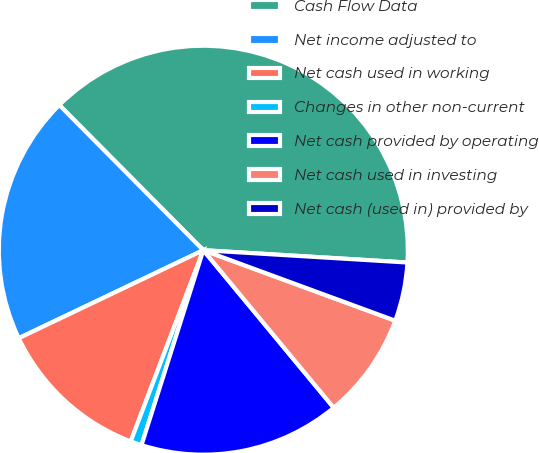Convert chart to OTSL. <chart><loc_0><loc_0><loc_500><loc_500><pie_chart><fcel>Cash Flow Data<fcel>Net income adjusted to<fcel>Net cash used in working<fcel>Changes in other non-current<fcel>Net cash provided by operating<fcel>Net cash used in investing<fcel>Net cash (used in) provided by<nl><fcel>38.39%<fcel>19.64%<fcel>12.14%<fcel>0.89%<fcel>15.89%<fcel>8.39%<fcel>4.64%<nl></chart> 